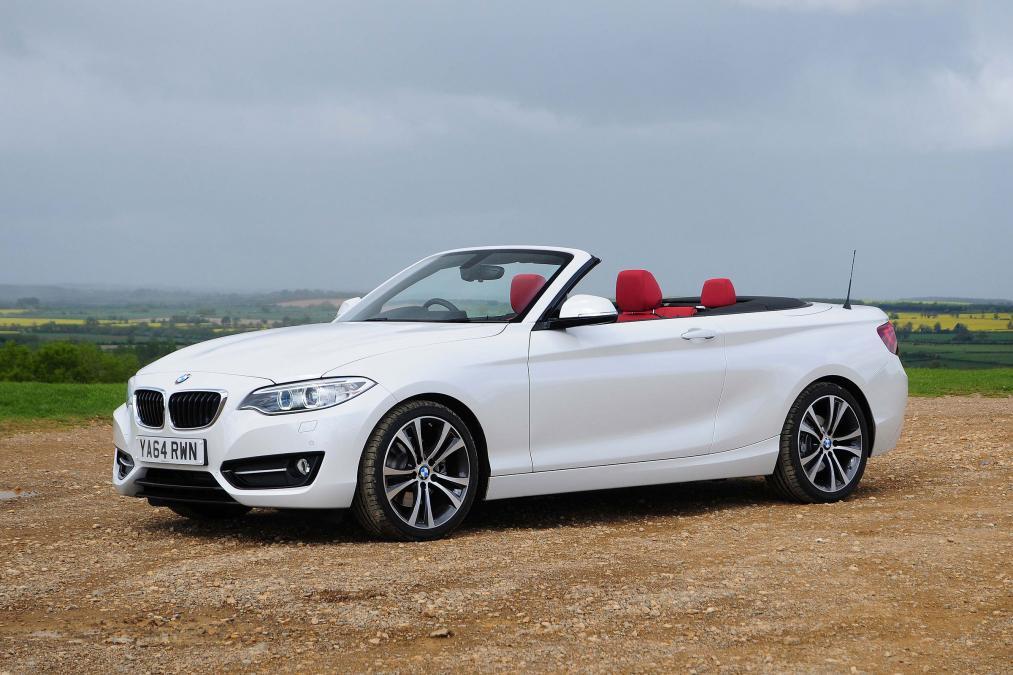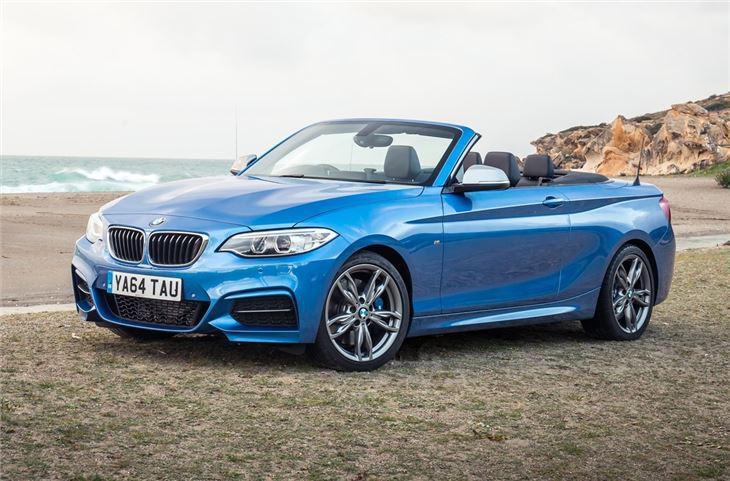The first image is the image on the left, the second image is the image on the right. Analyze the images presented: Is the assertion "One of ther cars is blue." valid? Answer yes or no. Yes. The first image is the image on the left, the second image is the image on the right. For the images displayed, is the sentence "Left image shows a white convertible driving down a paved road." factually correct? Answer yes or no. No. 